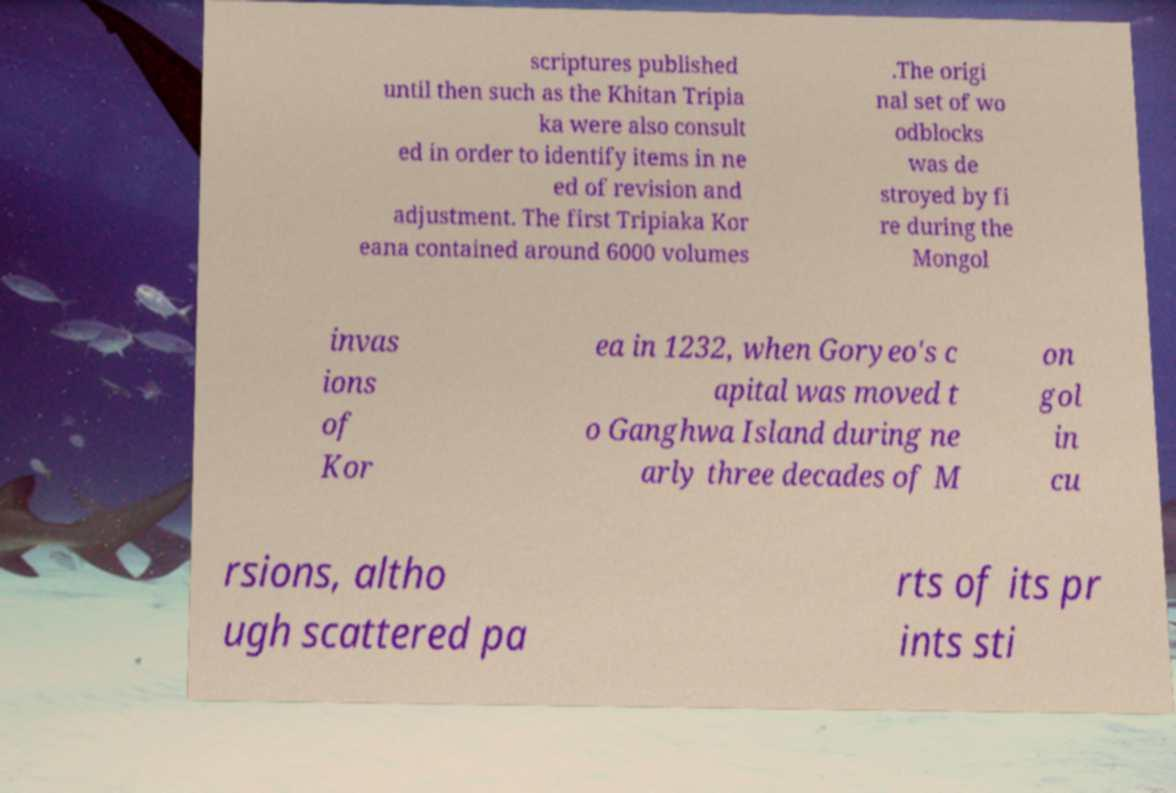What messages or text are displayed in this image? I need them in a readable, typed format. scriptures published until then such as the Khitan Tripia ka were also consult ed in order to identify items in ne ed of revision and adjustment. The first Tripiaka Kor eana contained around 6000 volumes .The origi nal set of wo odblocks was de stroyed by fi re during the Mongol invas ions of Kor ea in 1232, when Goryeo's c apital was moved t o Ganghwa Island during ne arly three decades of M on gol in cu rsions, altho ugh scattered pa rts of its pr ints sti 